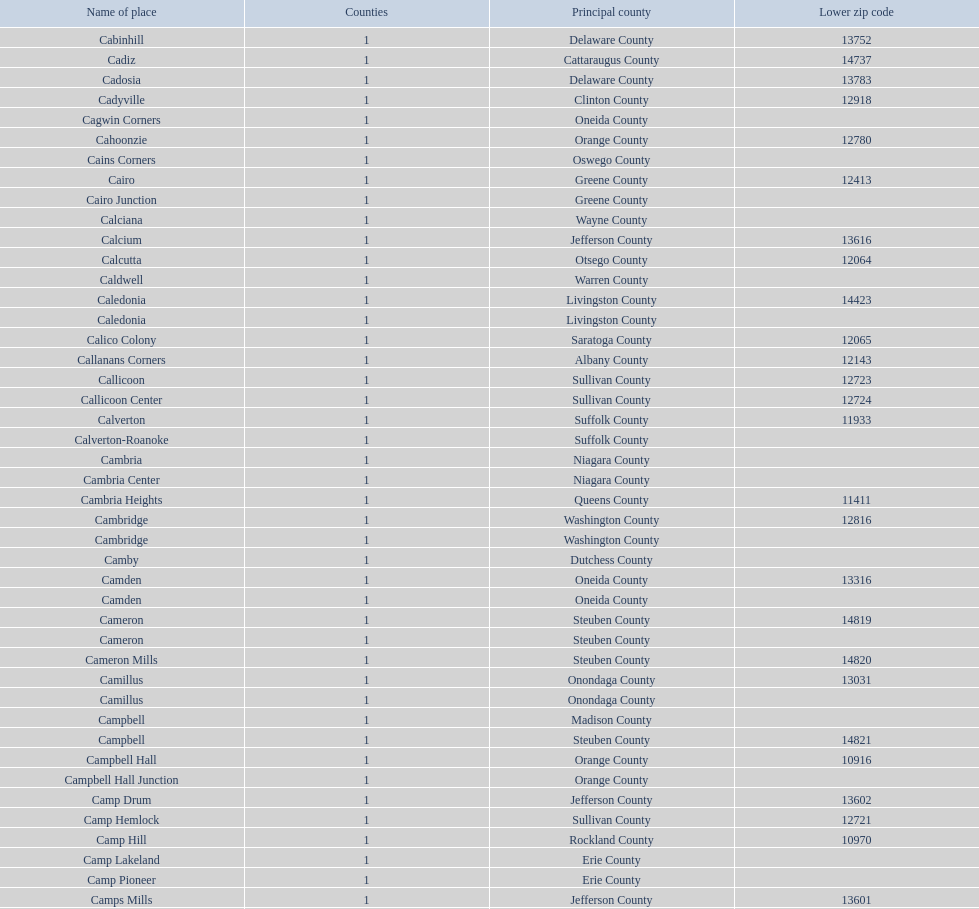Which location possesses the smallest zip code? Cooper. 